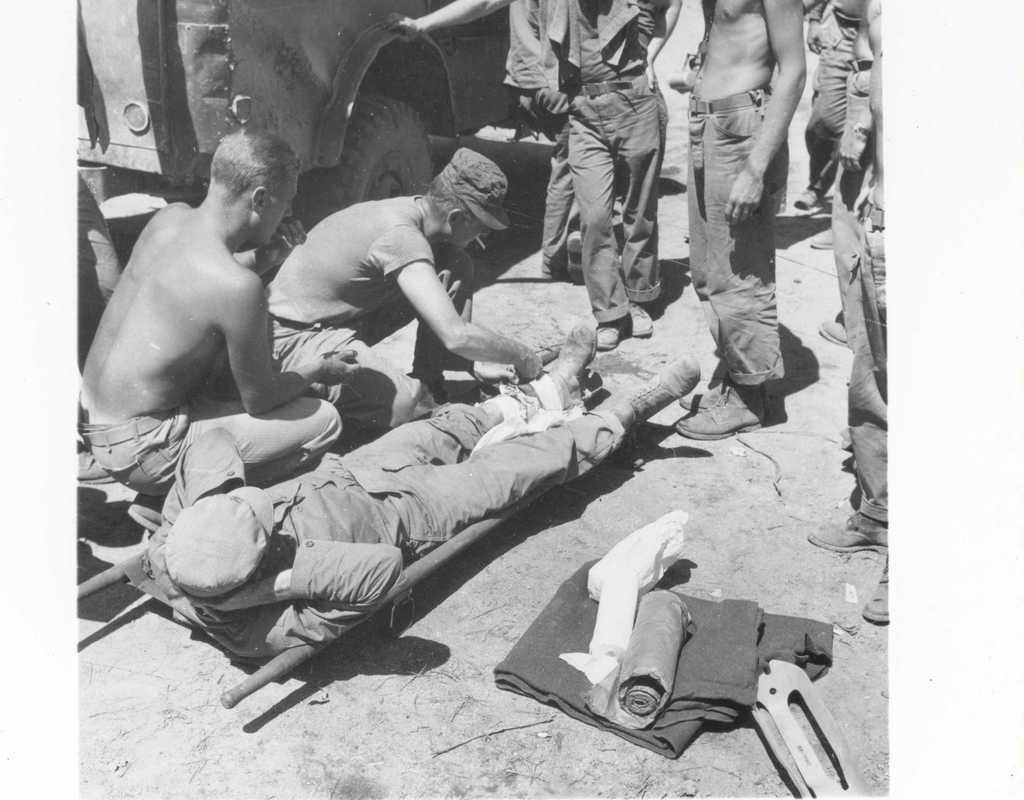Describe this image in one or two sentences. This is a black and white image. In the image there is a person lying on the stretcher. Beside him there are two men. And in the background there are few people standing. And also there is a vehicle in the background. 